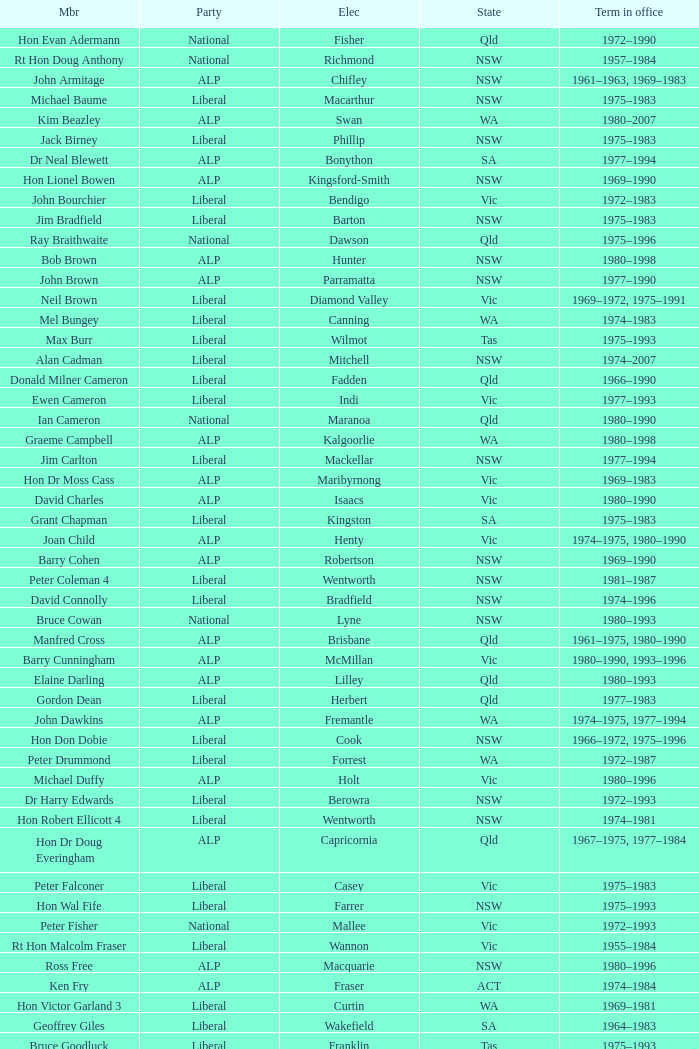To what party does Ralph Jacobi belong? ALP. 